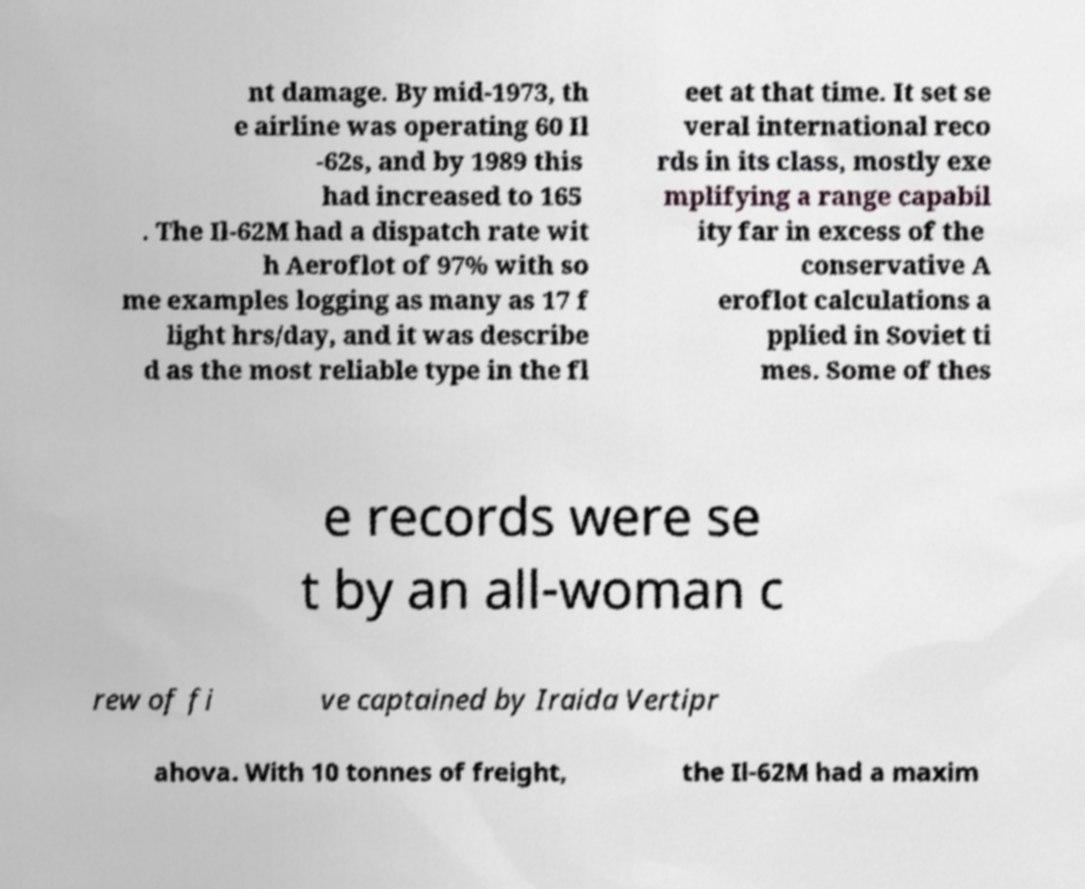Please read and relay the text visible in this image. What does it say? nt damage. By mid-1973, th e airline was operating 60 Il -62s, and by 1989 this had increased to 165 . The Il-62M had a dispatch rate wit h Aeroflot of 97% with so me examples logging as many as 17 f light hrs/day, and it was describe d as the most reliable type in the fl eet at that time. It set se veral international reco rds in its class, mostly exe mplifying a range capabil ity far in excess of the conservative A eroflot calculations a pplied in Soviet ti mes. Some of thes e records were se t by an all-woman c rew of fi ve captained by Iraida Vertipr ahova. With 10 tonnes of freight, the Il-62M had a maxim 